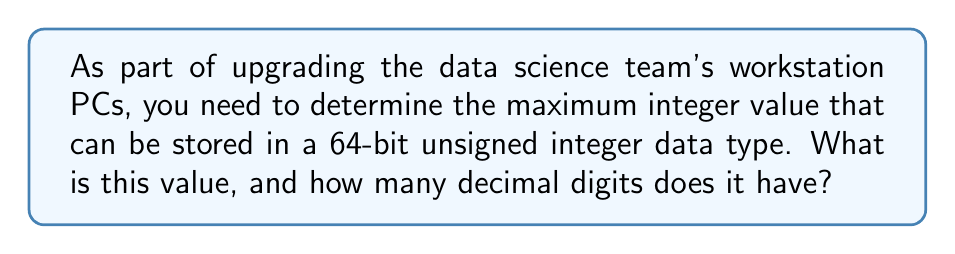Give your solution to this math problem. To solve this problem, let's follow these steps:

1) A 64-bit unsigned integer uses all 64 bits to represent positive numbers (including zero).

2) In binary, the largest number that can be represented is when all bits are 1. This is:

   $$1111...1111$$ (64 ones in total)

3) To convert this to decimal, we can use the formula for the sum of a geometric series:

   $$\sum_{i=0}^{n-1} 2^i = 2^n - 1$$

   Where $n$ is the number of bits, in this case, 64.

4) Therefore, the maximum value is:

   $$2^{64} - 1 = 18,446,744,073,709,551,615$$

5) To determine the number of decimal digits, we can use the logarithm:

   $$\text{Number of digits} = \lfloor \log_{10}(18,446,744,073,709,551,615) \rfloor + 1$$
   
   $$= \lfloor 19.2659... \rfloor + 1 = 19 + 1 = 20$$

   Where $\lfloor \cdot \rfloor$ denotes the floor function.

Thus, the maximum value has 20 decimal digits.
Answer: The maximum integer value that can be stored in a 64-bit unsigned integer is 18,446,744,073,709,551,615, and it has 20 decimal digits. 